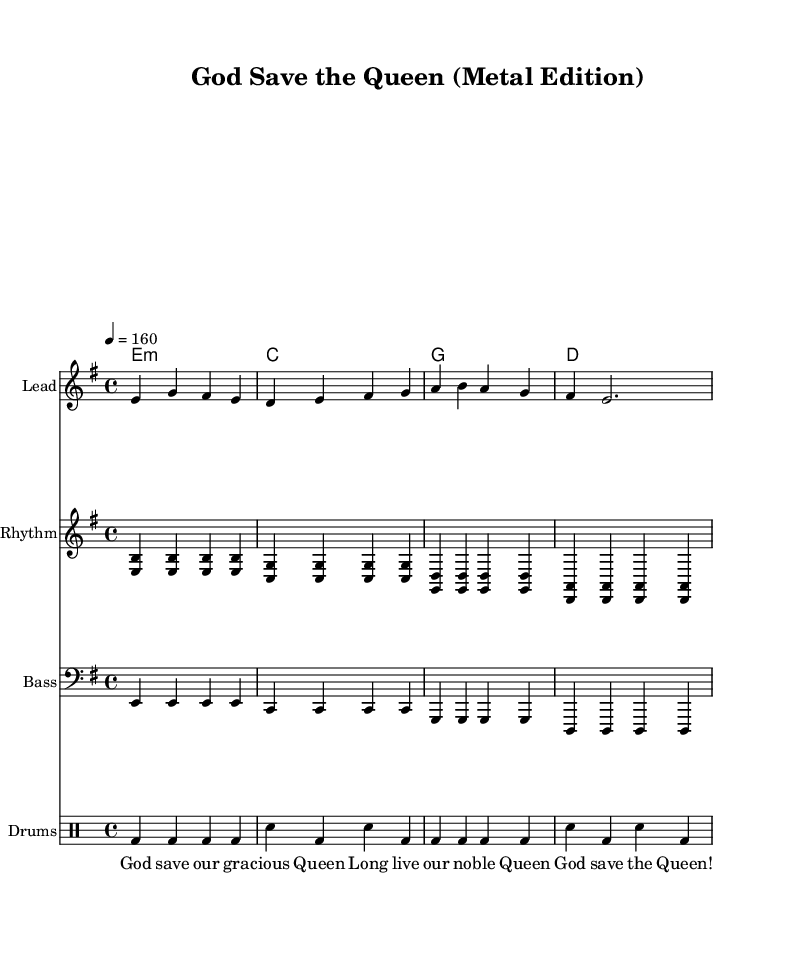What is the key signature of this music? The key signature is E minor, which has one sharp (F#). This can be identified by looking at the key signature at the beginning of the staff, which indicates E minor.
Answer: E minor What is the time signature of this piece? The time signature is 4/4, which means there are four beats in a measure and the quarter note gets one beat. This is noted at the beginning of the score next to the key signature.
Answer: 4/4 What is the tempo of the music? The tempo is marked at 160 beats per minute. This is indicated by the metronome marking at the beginning of the score, shown as "4 = 160".
Answer: 160 What is the final chord of the piece? The final chord is D major, which is indicated in the harmonies section as the last chord on the staff. Looking at the chord progression, the last chord listed corresponds to D major.
Answer: D major How many measures are there in total? There are four measures in this piece, which can be counted by looking across the melody, rhythm guitar, bass guitar, and drums part. Each part shows the same number of measures as they are aligned together.
Answer: 4 What type of metal style is represented in this cover? The style represented in this cover is characterized by heavy rhythms and power chords typical of metal music, which stands out in the rhythm guitar and bass parts with their aggressive chord progressions.
Answer: Heavy metal 